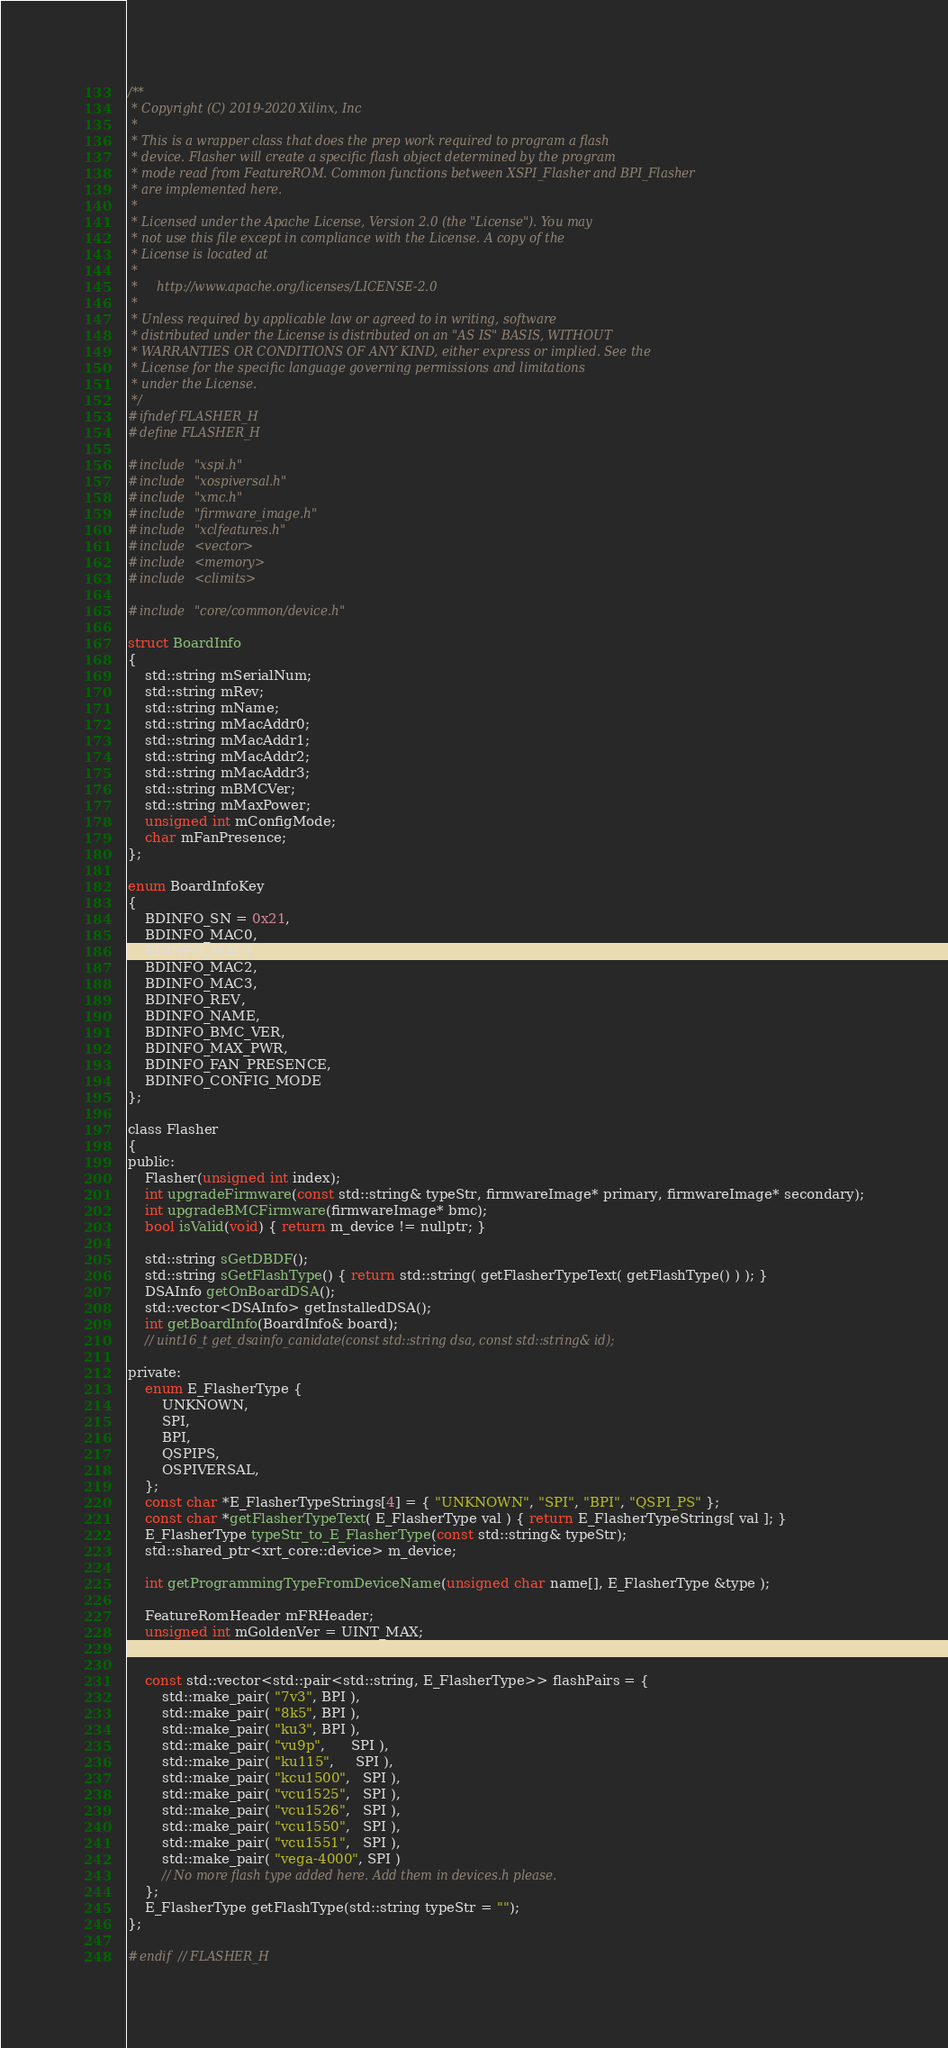Convert code to text. <code><loc_0><loc_0><loc_500><loc_500><_C_>/**
 * Copyright (C) 2019-2020 Xilinx, Inc
 *
 * This is a wrapper class that does the prep work required to program a flash
 * device. Flasher will create a specific flash object determined by the program
 * mode read from FeatureROM. Common functions between XSPI_Flasher and BPI_Flasher
 * are implemented here.
 *
 * Licensed under the Apache License, Version 2.0 (the "License"). You may
 * not use this file except in compliance with the License. A copy of the
 * License is located at
 *
 *     http://www.apache.org/licenses/LICENSE-2.0
 *
 * Unless required by applicable law or agreed to in writing, software
 * distributed under the License is distributed on an "AS IS" BASIS, WITHOUT
 * WARRANTIES OR CONDITIONS OF ANY KIND, either express or implied. See the
 * License for the specific language governing permissions and limitations
 * under the License.
 */
#ifndef FLASHER_H
#define FLASHER_H

#include "xspi.h"
#include "xospiversal.h"
#include "xmc.h"
#include "firmware_image.h"
#include "xclfeatures.h"
#include <vector>
#include <memory>
#include <climits>

#include "core/common/device.h"

struct BoardInfo
{
    std::string mSerialNum;
    std::string mRev;
    std::string mName;
    std::string mMacAddr0;
    std::string mMacAddr1;
    std::string mMacAddr2;
    std::string mMacAddr3;
    std::string mBMCVer;
    std::string mMaxPower;
    unsigned int mConfigMode;
    char mFanPresence;
};

enum BoardInfoKey
{
    BDINFO_SN = 0x21,
    BDINFO_MAC0,
    BDINFO_MAC1,
    BDINFO_MAC2,
    BDINFO_MAC3,
    BDINFO_REV,
    BDINFO_NAME,
    BDINFO_BMC_VER,
    BDINFO_MAX_PWR,
    BDINFO_FAN_PRESENCE,
    BDINFO_CONFIG_MODE
};

class Flasher
{
public:
    Flasher(unsigned int index);
    int upgradeFirmware(const std::string& typeStr, firmwareImage* primary, firmwareImage* secondary);
    int upgradeBMCFirmware(firmwareImage* bmc);
    bool isValid(void) { return m_device != nullptr; }

    std::string sGetDBDF();
    std::string sGetFlashType() { return std::string( getFlasherTypeText( getFlashType() ) ); }
    DSAInfo getOnBoardDSA();
    std::vector<DSAInfo> getInstalledDSA();
    int getBoardInfo(BoardInfo& board);
    // uint16_t get_dsainfo_canidate(const std::string dsa, const std::string& id);

private:
    enum E_FlasherType {
        UNKNOWN,
        SPI,
        BPI,
        QSPIPS,
        OSPIVERSAL,
    };
    const char *E_FlasherTypeStrings[4] = { "UNKNOWN", "SPI", "BPI", "QSPI_PS" };
    const char *getFlasherTypeText( E_FlasherType val ) { return E_FlasherTypeStrings[ val ]; }
    E_FlasherType typeStr_to_E_FlasherType(const std::string& typeStr); 
    std::shared_ptr<xrt_core::device> m_device;

    int getProgrammingTypeFromDeviceName(unsigned char name[], E_FlasherType &type );

    FeatureRomHeader mFRHeader;
    unsigned int mGoldenVer = UINT_MAX;
    

    const std::vector<std::pair<std::string, E_FlasherType>> flashPairs = {
        std::make_pair( "7v3", BPI ),
        std::make_pair( "8k5", BPI ),
        std::make_pair( "ku3", BPI ),
        std::make_pair( "vu9p",      SPI ),
        std::make_pair( "ku115",     SPI ),
        std::make_pair( "kcu1500",   SPI ),
        std::make_pair( "vcu1525",   SPI ),
        std::make_pair( "vcu1526",   SPI ),
        std::make_pair( "vcu1550",   SPI ),
        std::make_pair( "vcu1551",   SPI ),
        std::make_pair( "vega-4000", SPI )
        // No more flash type added here. Add them in devices.h please.
    };
    E_FlasherType getFlashType(std::string typeStr = "");
};

#endif // FLASHER_H
</code> 